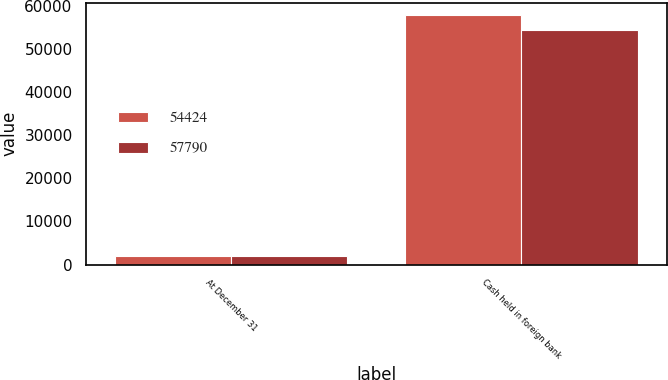Convert chart. <chart><loc_0><loc_0><loc_500><loc_500><stacked_bar_chart><ecel><fcel>At December 31<fcel>Cash held in foreign bank<nl><fcel>54424<fcel>2017<fcel>57790<nl><fcel>57790<fcel>2016<fcel>54424<nl></chart> 